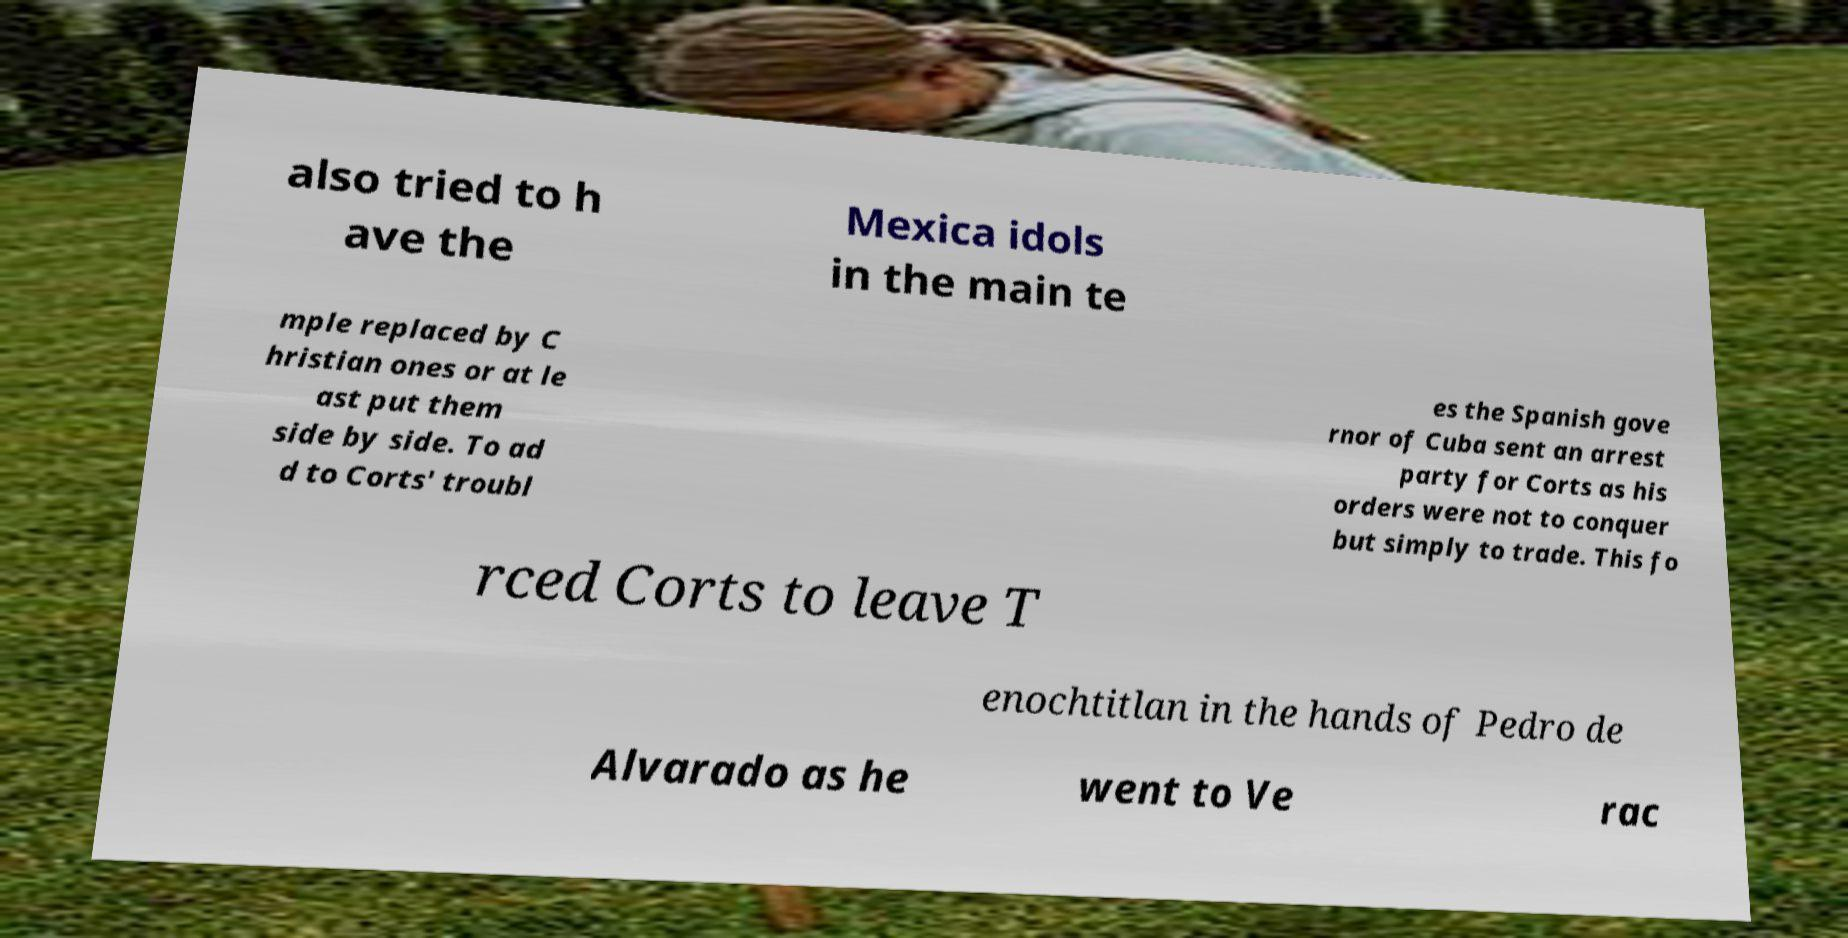I need the written content from this picture converted into text. Can you do that? also tried to h ave the Mexica idols in the main te mple replaced by C hristian ones or at le ast put them side by side. To ad d to Corts' troubl es the Spanish gove rnor of Cuba sent an arrest party for Corts as his orders were not to conquer but simply to trade. This fo rced Corts to leave T enochtitlan in the hands of Pedro de Alvarado as he went to Ve rac 